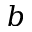<formula> <loc_0><loc_0><loc_500><loc_500>b</formula> 